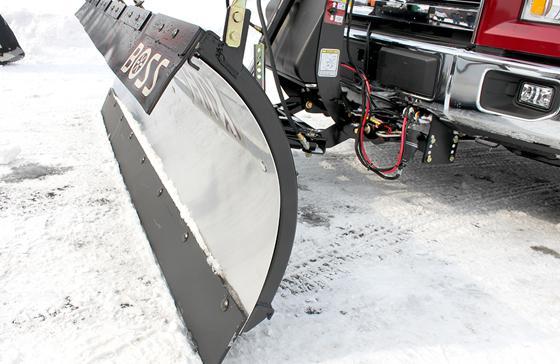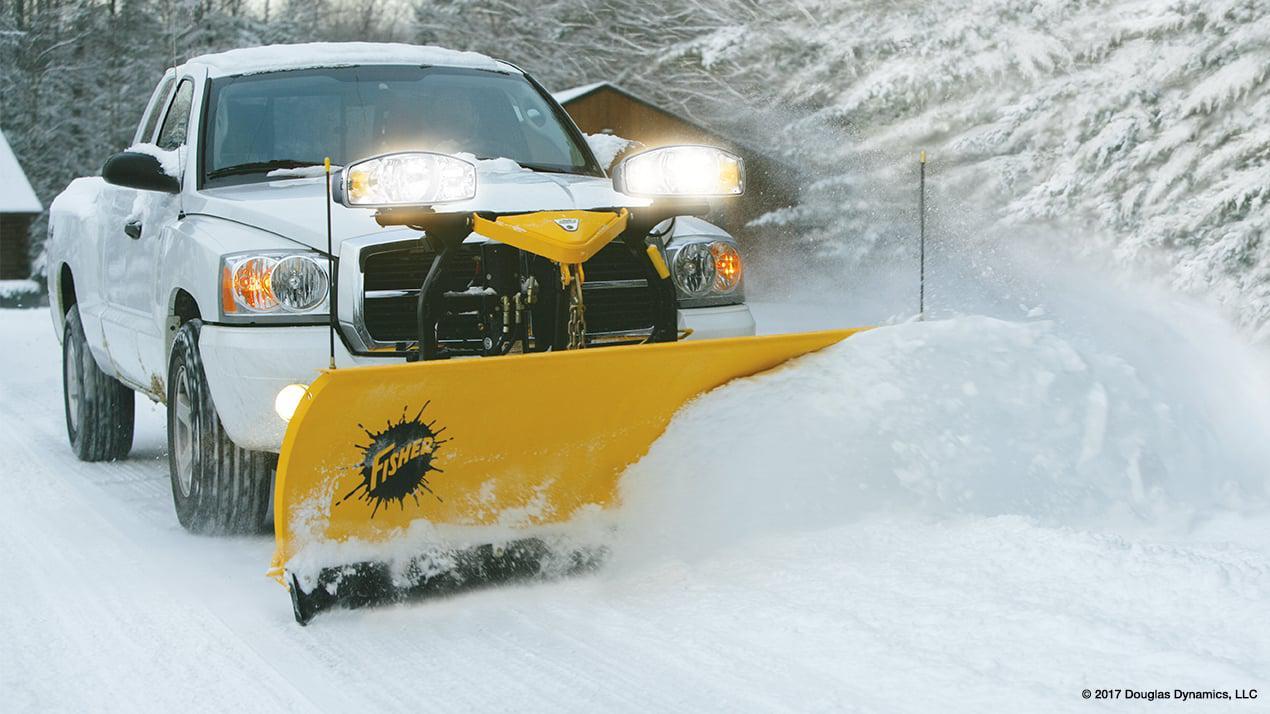The first image is the image on the left, the second image is the image on the right. For the images shown, is this caption "A truck with yellow bulldozer panel is pushing a pile of snow." true? Answer yes or no. Yes. The first image is the image on the left, the second image is the image on the right. Examine the images to the left and right. Is the description "All of the plows in the snow are yellow." accurate? Answer yes or no. No. 